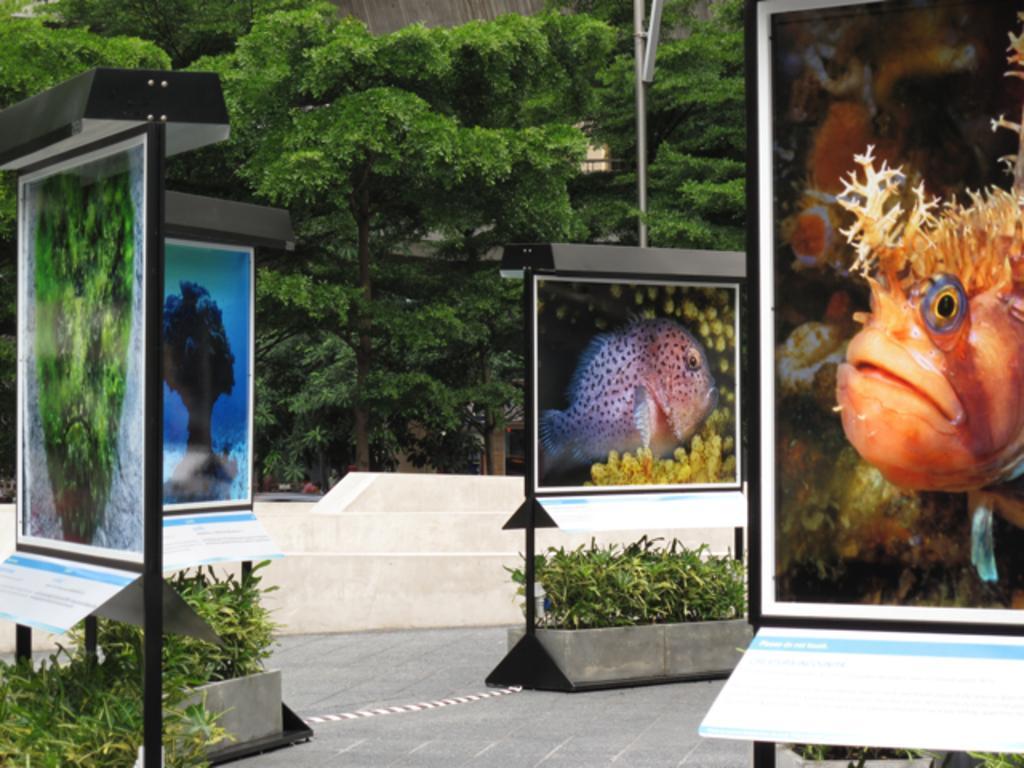Can you describe this image briefly? In this image I can see few boards are attached to the poles. I can see few fish and trees in the board. In the background I can see few trees in green color. 